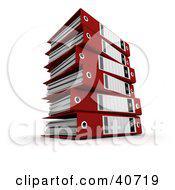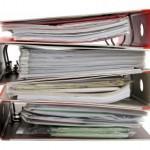The first image is the image on the left, the second image is the image on the right. For the images shown, is this caption "There is a collection of red binders." true? Answer yes or no. Yes. The first image is the image on the left, the second image is the image on the right. For the images displayed, is the sentence "In one image all the binders are red." factually correct? Answer yes or no. Yes. 